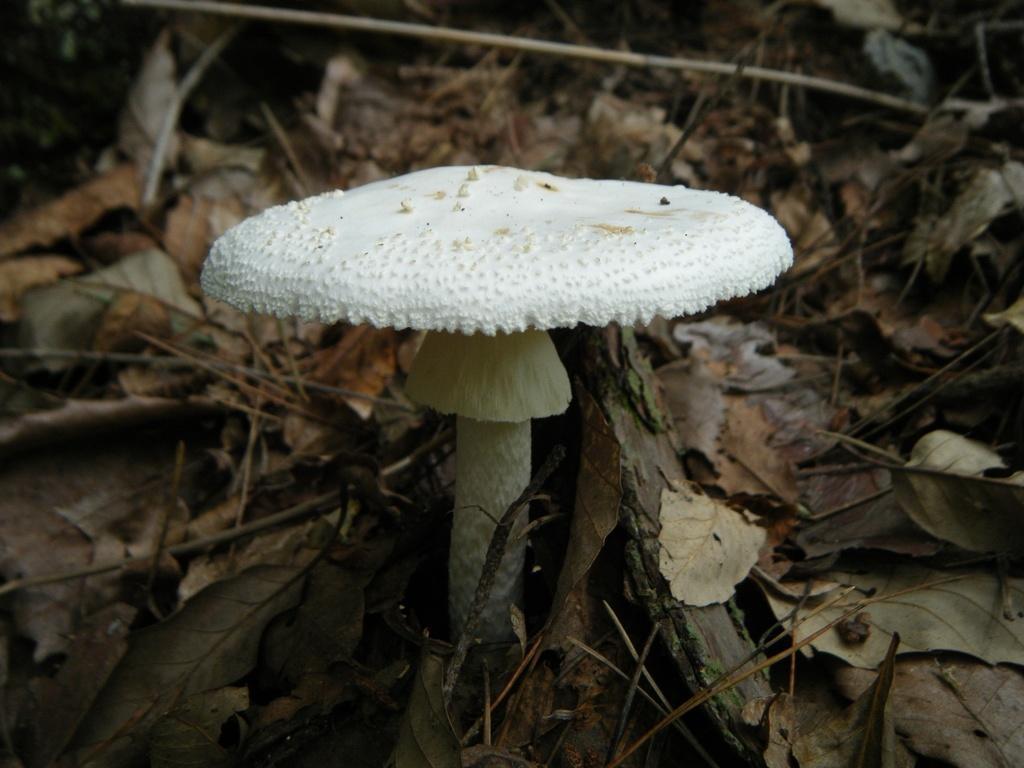Could you give a brief overview of what you see in this image? In this picture we can see white color mushroom plant in the front, surrounded with dry leaves. 